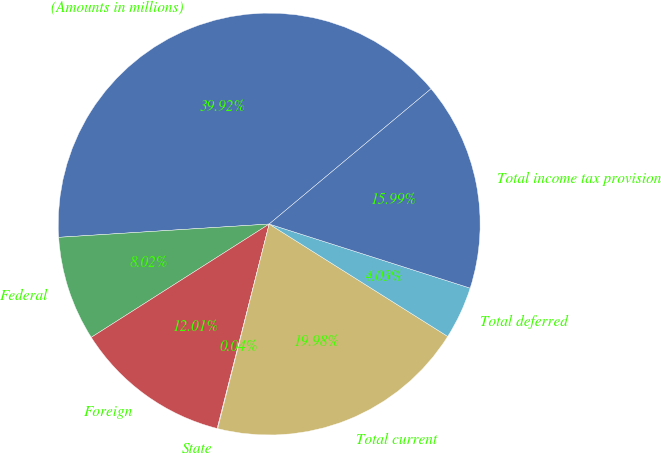Convert chart. <chart><loc_0><loc_0><loc_500><loc_500><pie_chart><fcel>(Amounts in millions)<fcel>Federal<fcel>Foreign<fcel>State<fcel>Total current<fcel>Total deferred<fcel>Total income tax provision<nl><fcel>39.92%<fcel>8.02%<fcel>12.01%<fcel>0.04%<fcel>19.98%<fcel>4.03%<fcel>15.99%<nl></chart> 